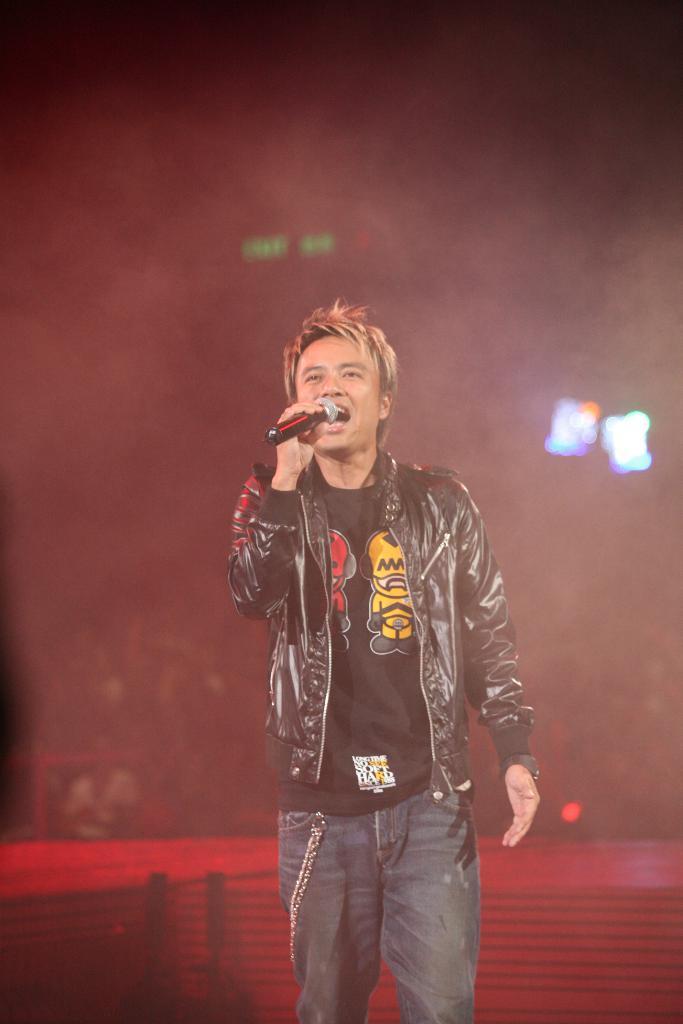Please provide a concise description of this image. This picture is clicked in the musical concert. The man in the middle of the picture wearing black T-shirt and black jacket is holding a microphone in his hand. He is singing the song on the microphone. Behind him, we see a stage in red color. In the background, it is blurred. On the right side, we see the lights. 